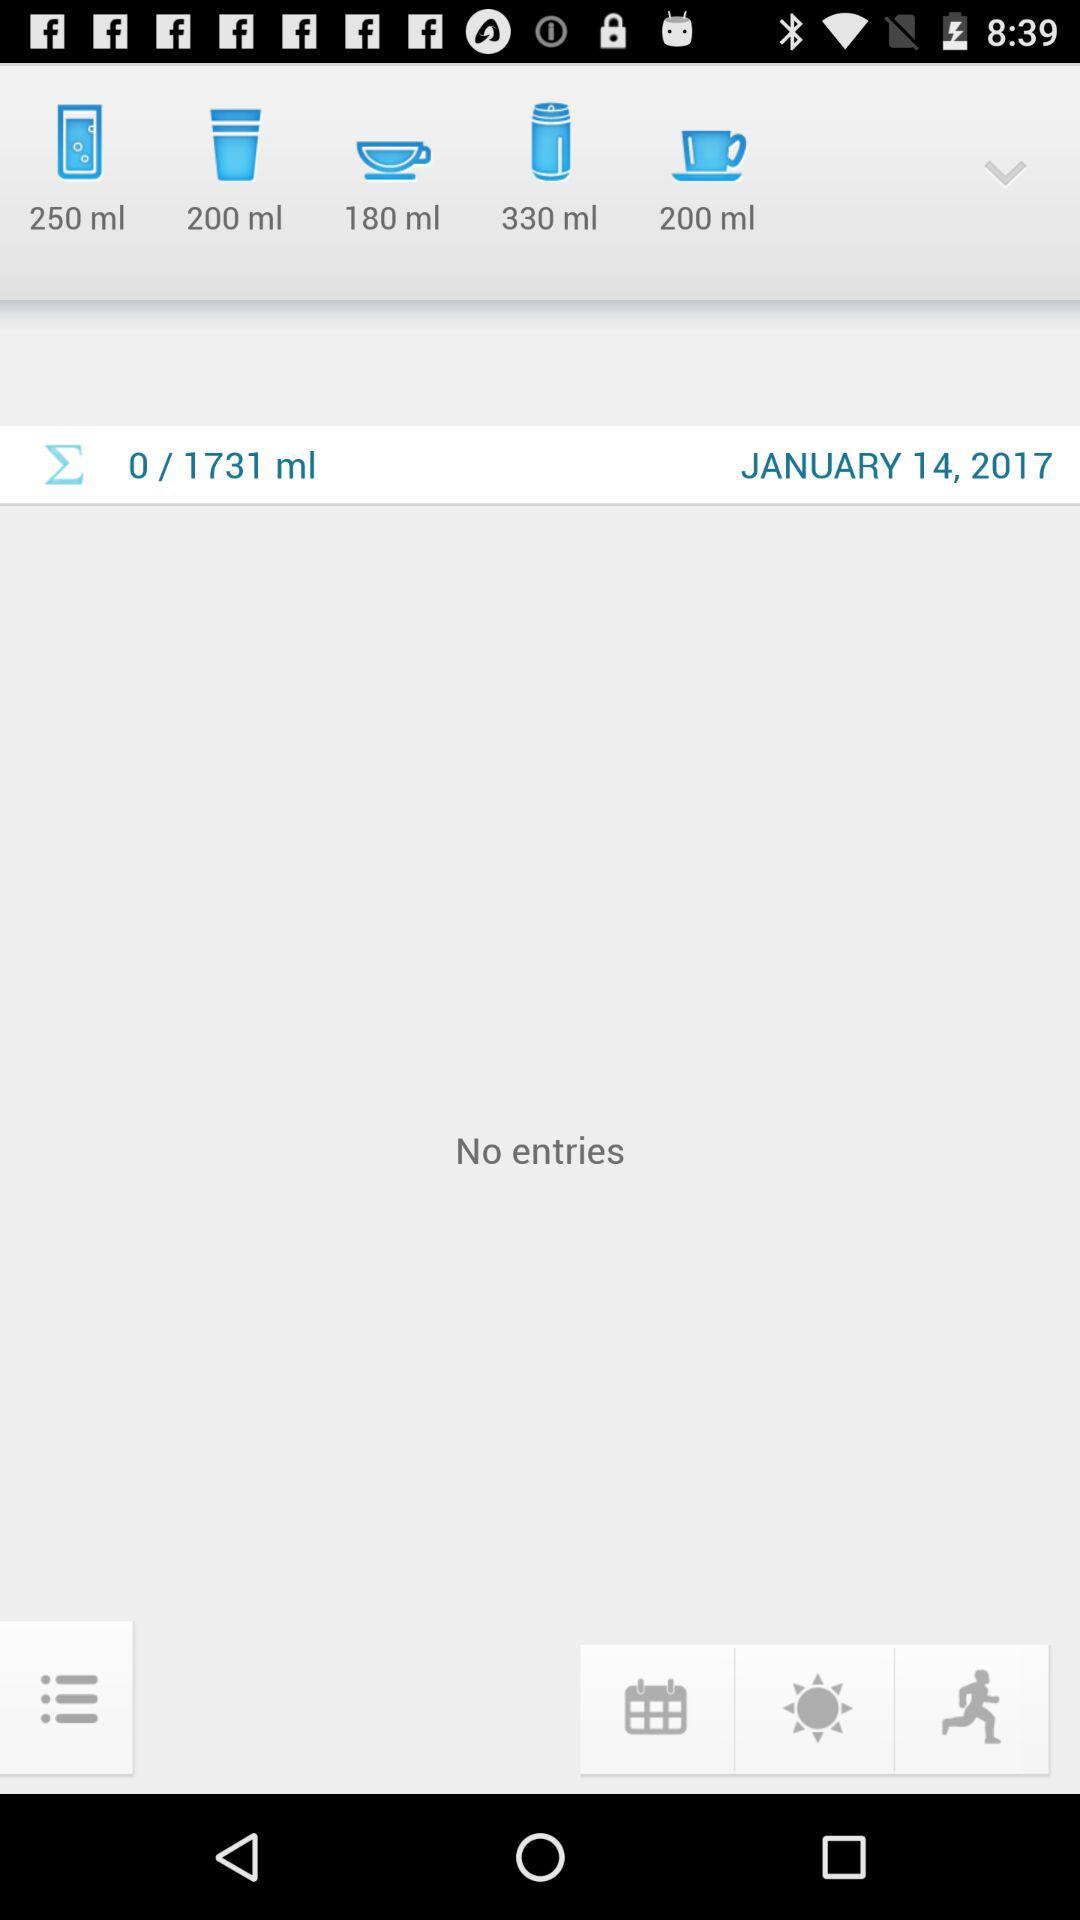What is the number of entries on January 14, 2017?
When the provided information is insufficient, respond with <no answer>. <no answer> 